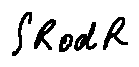<formula> <loc_0><loc_0><loc_500><loc_500>\int R o d R</formula> 